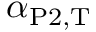<formula> <loc_0><loc_0><loc_500><loc_500>\alpha _ { P 2 , T }</formula> 